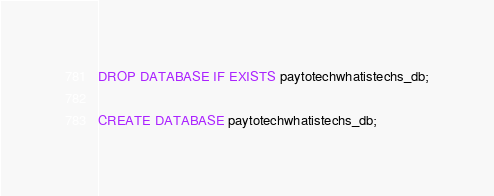<code> <loc_0><loc_0><loc_500><loc_500><_SQL_>DROP DATABASE IF EXISTS paytotechwhatistechs_db;

CREATE DATABASE paytotechwhatistechs_db;</code> 